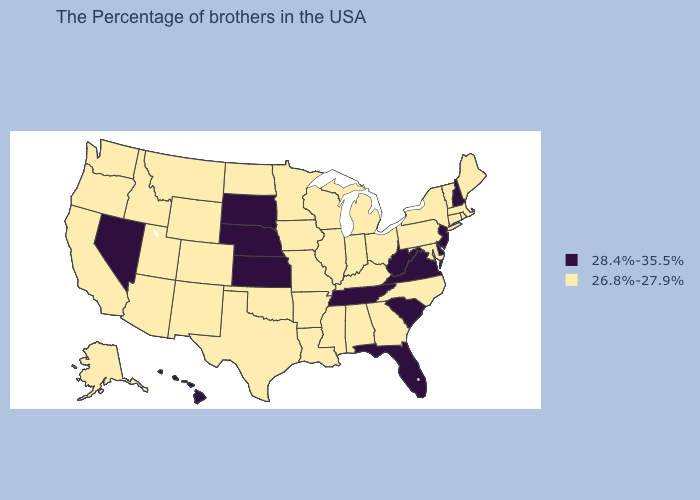Which states have the lowest value in the USA?
Short answer required. Maine, Massachusetts, Rhode Island, Vermont, Connecticut, New York, Maryland, Pennsylvania, North Carolina, Ohio, Georgia, Michigan, Kentucky, Indiana, Alabama, Wisconsin, Illinois, Mississippi, Louisiana, Missouri, Arkansas, Minnesota, Iowa, Oklahoma, Texas, North Dakota, Wyoming, Colorado, New Mexico, Utah, Montana, Arizona, Idaho, California, Washington, Oregon, Alaska. Does Oregon have a lower value than Hawaii?
Give a very brief answer. Yes. What is the value of Louisiana?
Short answer required. 26.8%-27.9%. Does Tennessee have the same value as Rhode Island?
Be succinct. No. Does the map have missing data?
Write a very short answer. No. How many symbols are there in the legend?
Short answer required. 2. Among the states that border Wisconsin , which have the lowest value?
Quick response, please. Michigan, Illinois, Minnesota, Iowa. Does New Mexico have the highest value in the West?
Be succinct. No. Does Nebraska have the lowest value in the USA?
Give a very brief answer. No. Does Michigan have the highest value in the USA?
Give a very brief answer. No. Does the map have missing data?
Write a very short answer. No. Name the states that have a value in the range 28.4%-35.5%?
Quick response, please. New Hampshire, New Jersey, Delaware, Virginia, South Carolina, West Virginia, Florida, Tennessee, Kansas, Nebraska, South Dakota, Nevada, Hawaii. Among the states that border Tennessee , does Missouri have the highest value?
Keep it brief. No. What is the value of Kentucky?
Answer briefly. 26.8%-27.9%. 